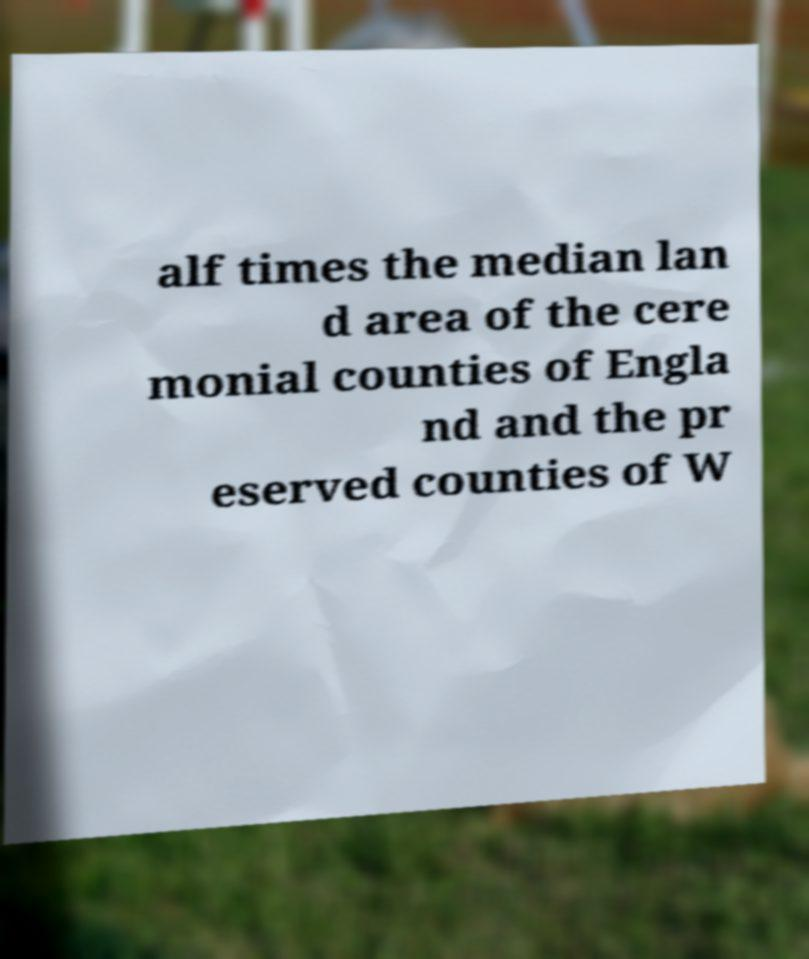For documentation purposes, I need the text within this image transcribed. Could you provide that? alf times the median lan d area of the cere monial counties of Engla nd and the pr eserved counties of W 